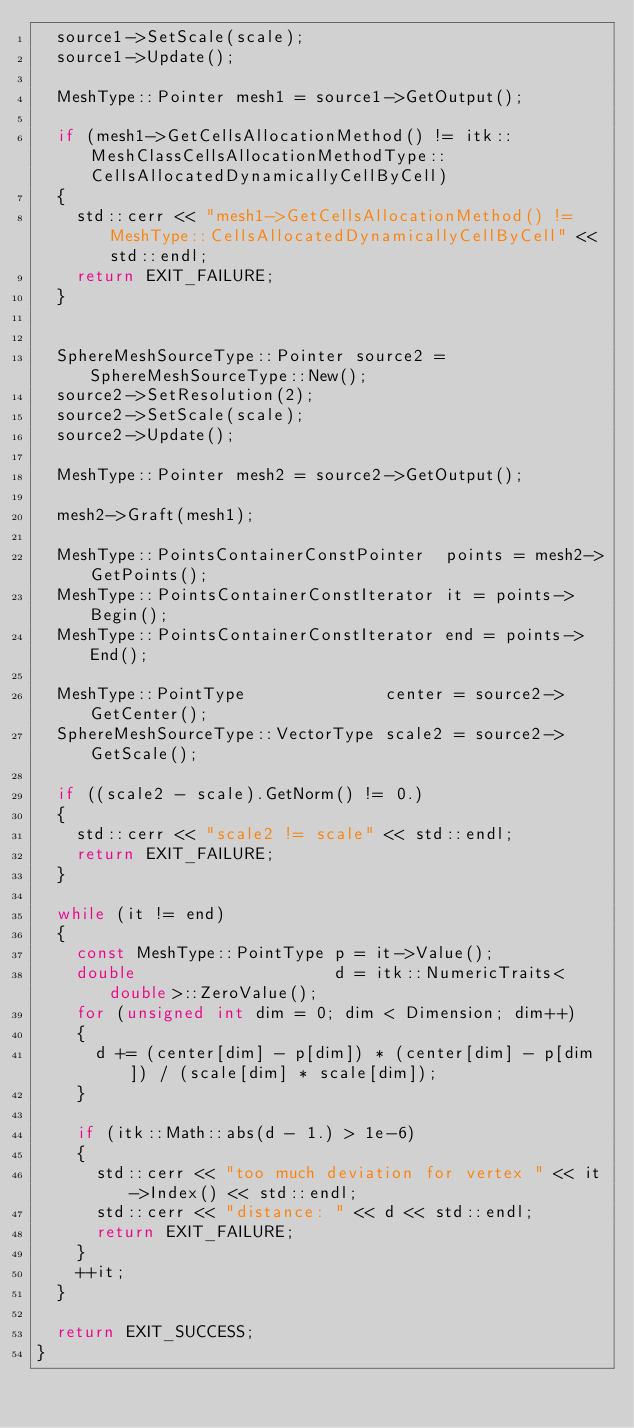Convert code to text. <code><loc_0><loc_0><loc_500><loc_500><_C++_>  source1->SetScale(scale);
  source1->Update();

  MeshType::Pointer mesh1 = source1->GetOutput();

  if (mesh1->GetCellsAllocationMethod() != itk::MeshClassCellsAllocationMethodType::CellsAllocatedDynamicallyCellByCell)
  {
    std::cerr << "mesh1->GetCellsAllocationMethod() != MeshType::CellsAllocatedDynamicallyCellByCell" << std::endl;
    return EXIT_FAILURE;
  }


  SphereMeshSourceType::Pointer source2 = SphereMeshSourceType::New();
  source2->SetResolution(2);
  source2->SetScale(scale);
  source2->Update();

  MeshType::Pointer mesh2 = source2->GetOutput();

  mesh2->Graft(mesh1);

  MeshType::PointsContainerConstPointer  points = mesh2->GetPoints();
  MeshType::PointsContainerConstIterator it = points->Begin();
  MeshType::PointsContainerConstIterator end = points->End();

  MeshType::PointType              center = source2->GetCenter();
  SphereMeshSourceType::VectorType scale2 = source2->GetScale();

  if ((scale2 - scale).GetNorm() != 0.)
  {
    std::cerr << "scale2 != scale" << std::endl;
    return EXIT_FAILURE;
  }

  while (it != end)
  {
    const MeshType::PointType p = it->Value();
    double                    d = itk::NumericTraits<double>::ZeroValue();
    for (unsigned int dim = 0; dim < Dimension; dim++)
    {
      d += (center[dim] - p[dim]) * (center[dim] - p[dim]) / (scale[dim] * scale[dim]);
    }

    if (itk::Math::abs(d - 1.) > 1e-6)
    {
      std::cerr << "too much deviation for vertex " << it->Index() << std::endl;
      std::cerr << "distance: " << d << std::endl;
      return EXIT_FAILURE;
    }
    ++it;
  }

  return EXIT_SUCCESS;
}
</code> 